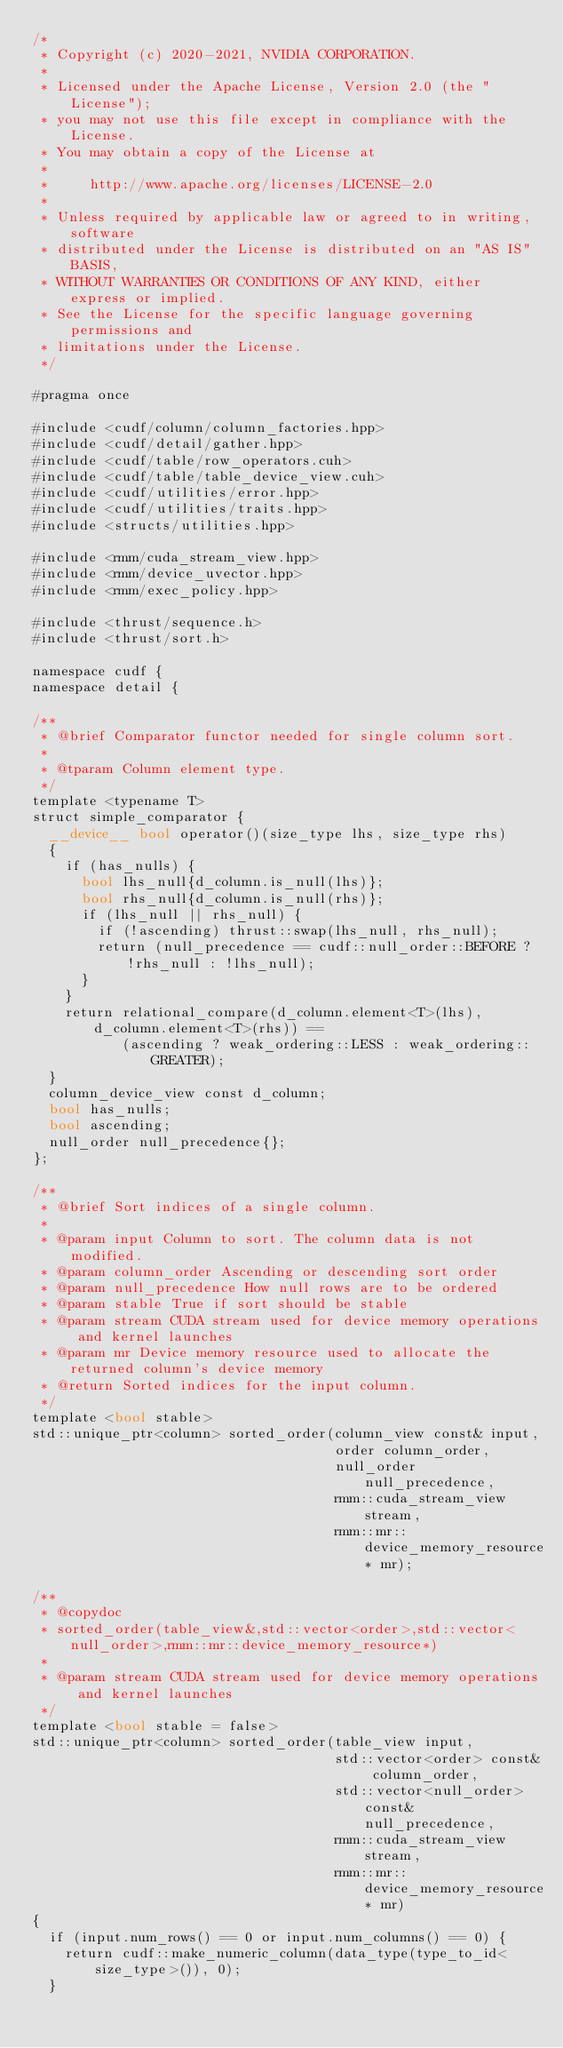<code> <loc_0><loc_0><loc_500><loc_500><_Cuda_>/*
 * Copyright (c) 2020-2021, NVIDIA CORPORATION.
 *
 * Licensed under the Apache License, Version 2.0 (the "License");
 * you may not use this file except in compliance with the License.
 * You may obtain a copy of the License at
 *
 *     http://www.apache.org/licenses/LICENSE-2.0
 *
 * Unless required by applicable law or agreed to in writing, software
 * distributed under the License is distributed on an "AS IS" BASIS,
 * WITHOUT WARRANTIES OR CONDITIONS OF ANY KIND, either express or implied.
 * See the License for the specific language governing permissions and
 * limitations under the License.
 */

#pragma once

#include <cudf/column/column_factories.hpp>
#include <cudf/detail/gather.hpp>
#include <cudf/table/row_operators.cuh>
#include <cudf/table/table_device_view.cuh>
#include <cudf/utilities/error.hpp>
#include <cudf/utilities/traits.hpp>
#include <structs/utilities.hpp>

#include <rmm/cuda_stream_view.hpp>
#include <rmm/device_uvector.hpp>
#include <rmm/exec_policy.hpp>

#include <thrust/sequence.h>
#include <thrust/sort.h>

namespace cudf {
namespace detail {

/**
 * @brief Comparator functor needed for single column sort.
 *
 * @tparam Column element type.
 */
template <typename T>
struct simple_comparator {
  __device__ bool operator()(size_type lhs, size_type rhs)
  {
    if (has_nulls) {
      bool lhs_null{d_column.is_null(lhs)};
      bool rhs_null{d_column.is_null(rhs)};
      if (lhs_null || rhs_null) {
        if (!ascending) thrust::swap(lhs_null, rhs_null);
        return (null_precedence == cudf::null_order::BEFORE ? !rhs_null : !lhs_null);
      }
    }
    return relational_compare(d_column.element<T>(lhs), d_column.element<T>(rhs)) ==
           (ascending ? weak_ordering::LESS : weak_ordering::GREATER);
  }
  column_device_view const d_column;
  bool has_nulls;
  bool ascending;
  null_order null_precedence{};
};

/**
 * @brief Sort indices of a single column.
 *
 * @param input Column to sort. The column data is not modified.
 * @param column_order Ascending or descending sort order
 * @param null_precedence How null rows are to be ordered
 * @param stable True if sort should be stable
 * @param stream CUDA stream used for device memory operations and kernel launches
 * @param mr Device memory resource used to allocate the returned column's device memory
 * @return Sorted indices for the input column.
 */
template <bool stable>
std::unique_ptr<column> sorted_order(column_view const& input,
                                     order column_order,
                                     null_order null_precedence,
                                     rmm::cuda_stream_view stream,
                                     rmm::mr::device_memory_resource* mr);

/**
 * @copydoc
 * sorted_order(table_view&,std::vector<order>,std::vector<null_order>,rmm::mr::device_memory_resource*)
 *
 * @param stream CUDA stream used for device memory operations and kernel launches
 */
template <bool stable = false>
std::unique_ptr<column> sorted_order(table_view input,
                                     std::vector<order> const& column_order,
                                     std::vector<null_order> const& null_precedence,
                                     rmm::cuda_stream_view stream,
                                     rmm::mr::device_memory_resource* mr)
{
  if (input.num_rows() == 0 or input.num_columns() == 0) {
    return cudf::make_numeric_column(data_type(type_to_id<size_type>()), 0);
  }
</code> 